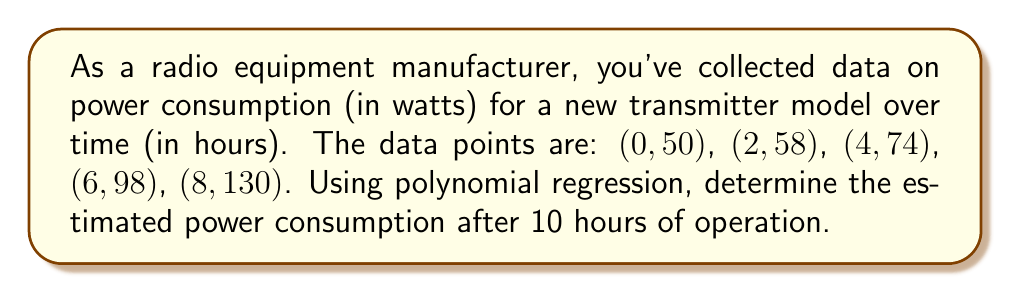Give your solution to this math problem. To solve this problem, we'll use quadratic polynomial regression, as it often provides a good balance between fitting the data and avoiding overfitting. We'll follow these steps:

1) The general form of a quadratic polynomial is:
   $$f(x) = ax^2 + bx + c$$

2) We need to find the values of $a$, $b$, and $c$ that best fit our data. We can use a system of normal equations or a matrix method, but for simplicity, we'll use a polynomial regression calculator.

3) Inputting our data points (0, 50), (2, 58), (4, 74), (6, 98), (8, 130) into a polynomial regression calculator, we get the following equation:
   $$f(x) = 0.9375x^2 + 2.125x + 50$$

4) To estimate the power consumption after 10 hours, we substitute $x = 10$ into our equation:

   $$\begin{align}
   f(10) &= 0.9375(10)^2 + 2.125(10) + 50 \\
   &= 0.9375(100) + 21.25 + 50 \\
   &= 93.75 + 21.25 + 50 \\
   &= 165
   \end{align}$$

5) Therefore, the estimated power consumption after 10 hours is 165 watts.

Note: This estimation assumes that the quadratic trend continues beyond the given data points. In practice, you should verify if this assumption holds for your specific equipment.
Answer: 165 watts 